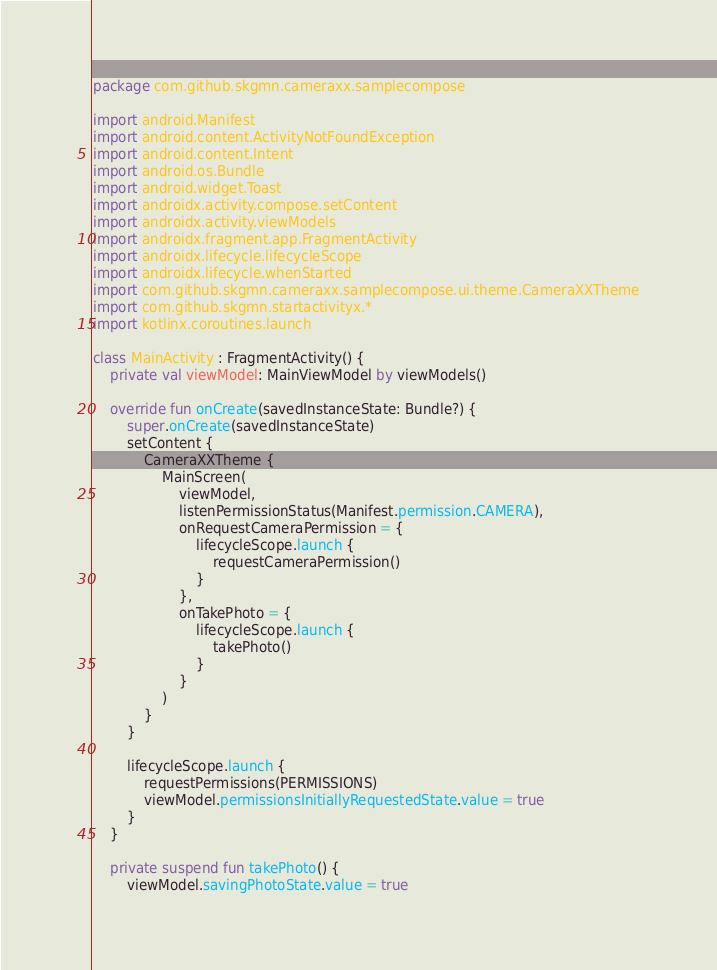<code> <loc_0><loc_0><loc_500><loc_500><_Kotlin_>package com.github.skgmn.cameraxx.samplecompose

import android.Manifest
import android.content.ActivityNotFoundException
import android.content.Intent
import android.os.Bundle
import android.widget.Toast
import androidx.activity.compose.setContent
import androidx.activity.viewModels
import androidx.fragment.app.FragmentActivity
import androidx.lifecycle.lifecycleScope
import androidx.lifecycle.whenStarted
import com.github.skgmn.cameraxx.samplecompose.ui.theme.CameraXXTheme
import com.github.skgmn.startactivityx.*
import kotlinx.coroutines.launch

class MainActivity : FragmentActivity() {
    private val viewModel: MainViewModel by viewModels()

    override fun onCreate(savedInstanceState: Bundle?) {
        super.onCreate(savedInstanceState)
        setContent {
            CameraXXTheme {
                MainScreen(
                    viewModel,
                    listenPermissionStatus(Manifest.permission.CAMERA),
                    onRequestCameraPermission = {
                        lifecycleScope.launch {
                            requestCameraPermission()
                        }
                    },
                    onTakePhoto = {
                        lifecycleScope.launch {
                            takePhoto()
                        }
                    }
                )
            }
        }

        lifecycleScope.launch {
            requestPermissions(PERMISSIONS)
            viewModel.permissionsInitiallyRequestedState.value = true
        }
    }

    private suspend fun takePhoto() {
        viewModel.savingPhotoState.value = true</code> 